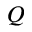Convert formula to latex. <formula><loc_0><loc_0><loc_500><loc_500>Q</formula> 